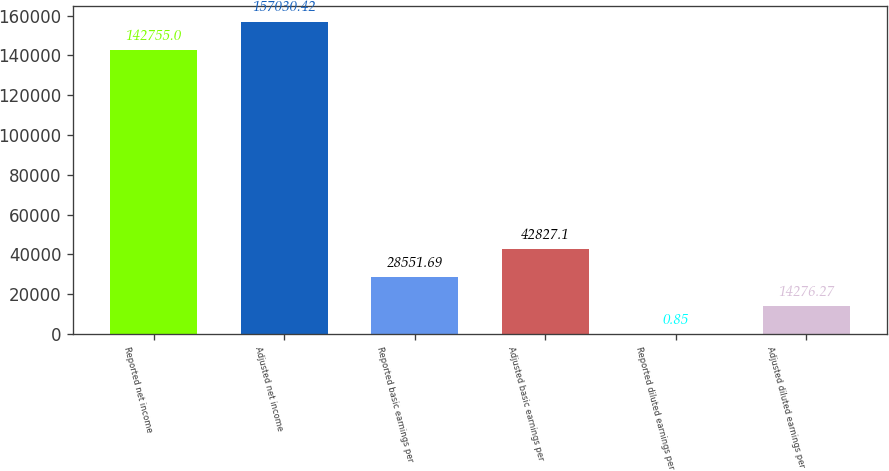Convert chart. <chart><loc_0><loc_0><loc_500><loc_500><bar_chart><fcel>Reported net income<fcel>Adjusted net income<fcel>Reported basic earnings per<fcel>Adjusted basic earnings per<fcel>Reported diluted earnings per<fcel>Adjusted diluted earnings per<nl><fcel>142755<fcel>157030<fcel>28551.7<fcel>42827.1<fcel>0.85<fcel>14276.3<nl></chart> 